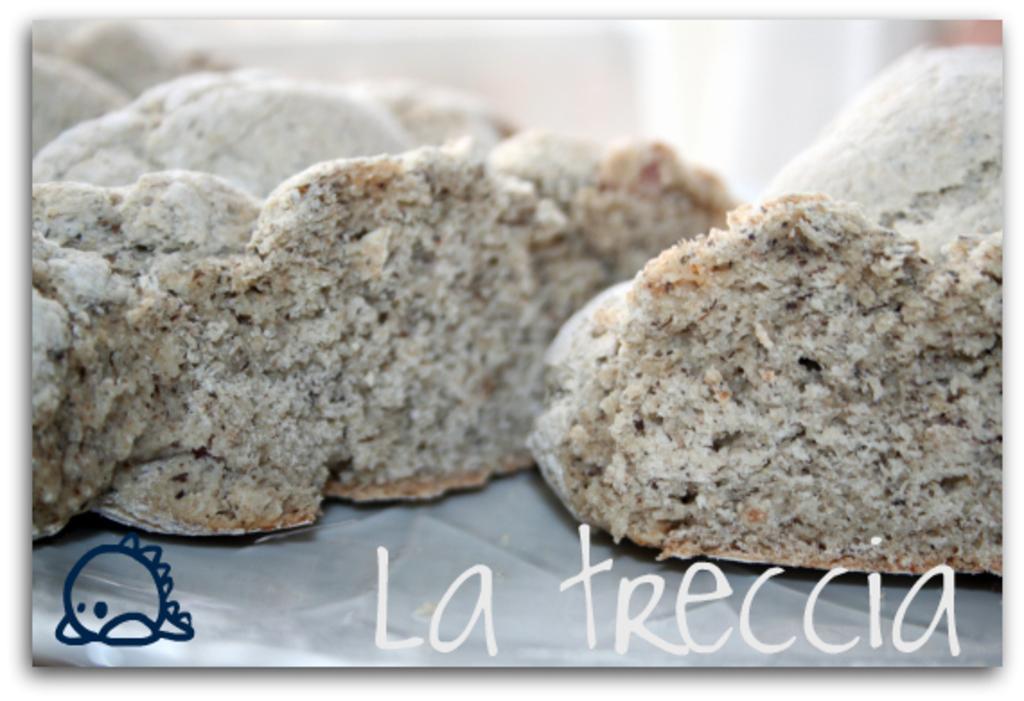Please provide a concise description of this image. At the bottom of this image, there are watermarks. In the middle of this image, there are food items arranged on a surface. And the background is blurred. 